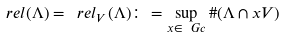<formula> <loc_0><loc_0><loc_500><loc_500>\ r e l ( \Lambda ) = \ r e l _ { V } ( \Lambda ) \colon = \sup _ { x \in \ G c } \# ( \Lambda \cap x V )</formula> 